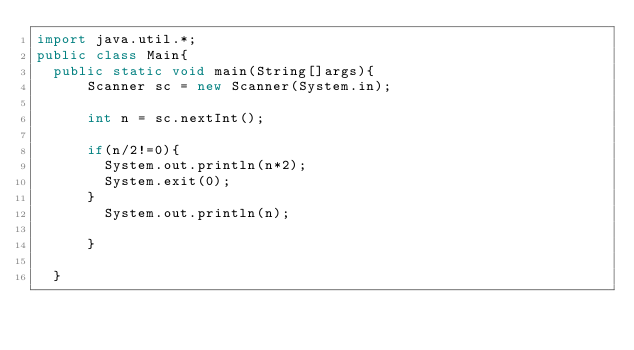Convert code to text. <code><loc_0><loc_0><loc_500><loc_500><_Java_>import java.util.*;
public class Main{
  public static void main(String[]args){
      Scanner sc = new Scanner(System.in);

      int n = sc.nextInt();

      if(n/2!=0){
        System.out.println(n*2);
        System.exit(0);
      }
        System.out.println(n);
      
      }

  }
</code> 